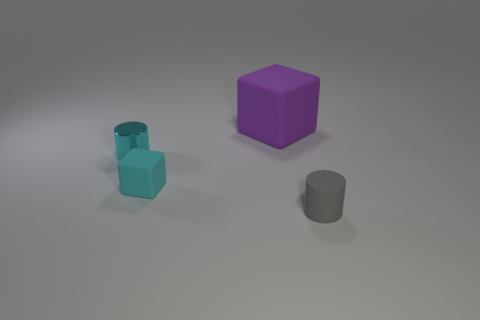Are there any gray rubber objects behind the tiny thing in front of the tiny rubber object that is behind the gray rubber cylinder? After examining the image, I can confirm that there are no gray rubber objects positioned behind the small object located in front of the smaller rubber item, which, in turn, is located behind the gray rubber cylinder. The only visible objects are the ones in clear view, with no additional items obscured from sight. 